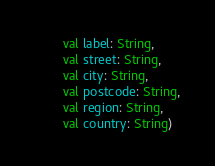<code> <loc_0><loc_0><loc_500><loc_500><_Kotlin_>        val label: String,
        val street: String,
        val city: String,
        val postcode: String,
        val region: String,
        val country: String)
</code> 